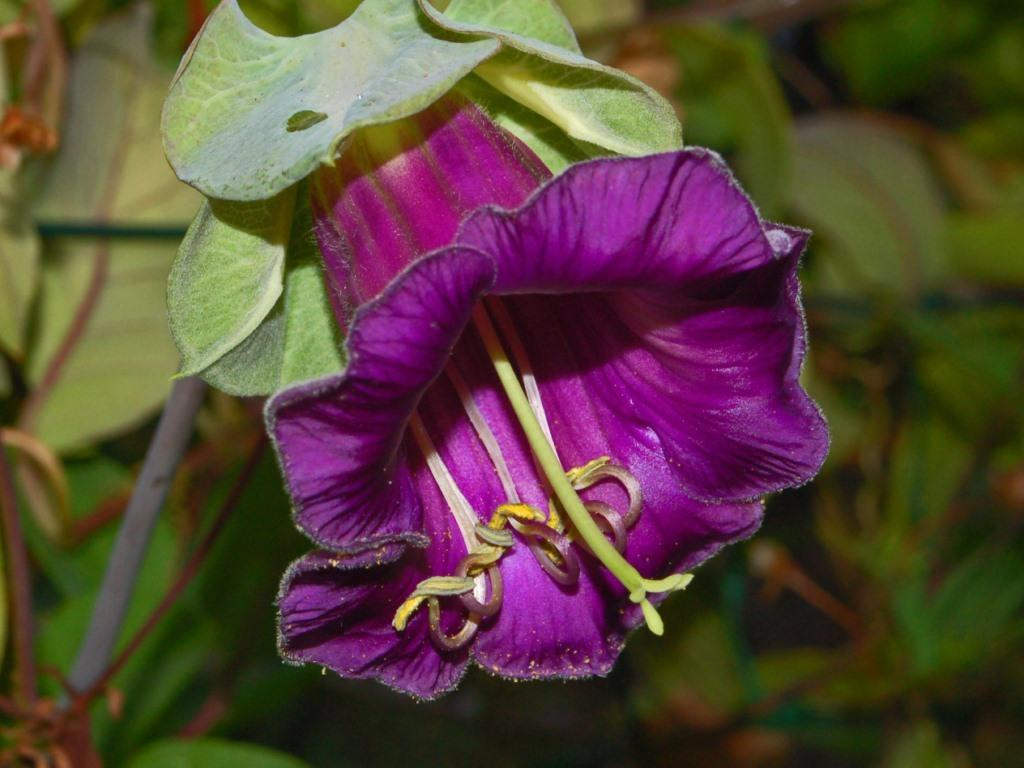What type of plant can be seen in the image? There is a flower in the image. What color are the leaves associated with the flower? There are green leaves in the image. What language is the farmer speaking in the image? There is no farmer present in the image, so it is not possible to determine what language they might be speaking. 